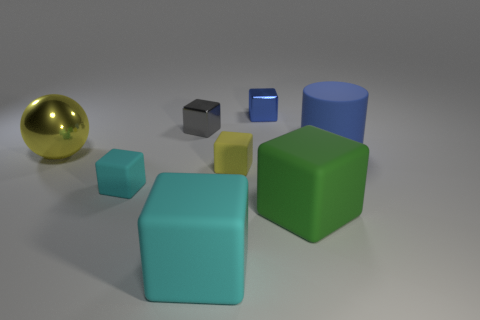Subtract 2 blocks. How many blocks are left? 4 Subtract all blue cubes. How many cubes are left? 5 Subtract all cyan rubber cubes. How many cubes are left? 4 Subtract all brown cubes. Subtract all purple cylinders. How many cubes are left? 6 Add 1 large rubber blocks. How many objects exist? 9 Subtract all cylinders. How many objects are left? 7 Subtract all small yellow cubes. Subtract all big yellow spheres. How many objects are left? 6 Add 5 gray shiny blocks. How many gray shiny blocks are left? 6 Add 2 cyan things. How many cyan things exist? 4 Subtract 0 blue balls. How many objects are left? 8 